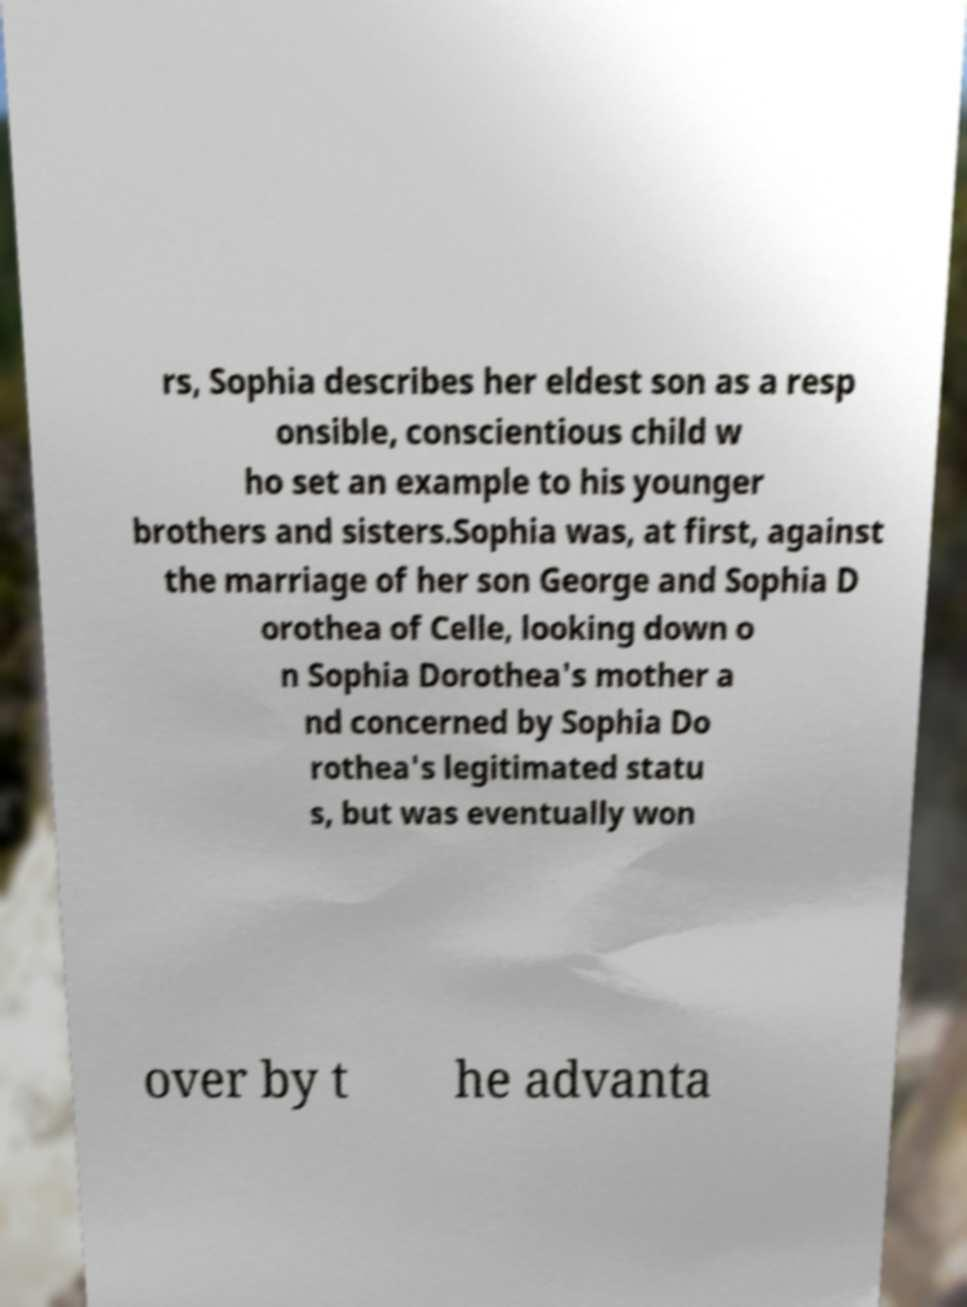What messages or text are displayed in this image? I need them in a readable, typed format. rs, Sophia describes her eldest son as a resp onsible, conscientious child w ho set an example to his younger brothers and sisters.Sophia was, at first, against the marriage of her son George and Sophia D orothea of Celle, looking down o n Sophia Dorothea's mother a nd concerned by Sophia Do rothea's legitimated statu s, but was eventually won over by t he advanta 